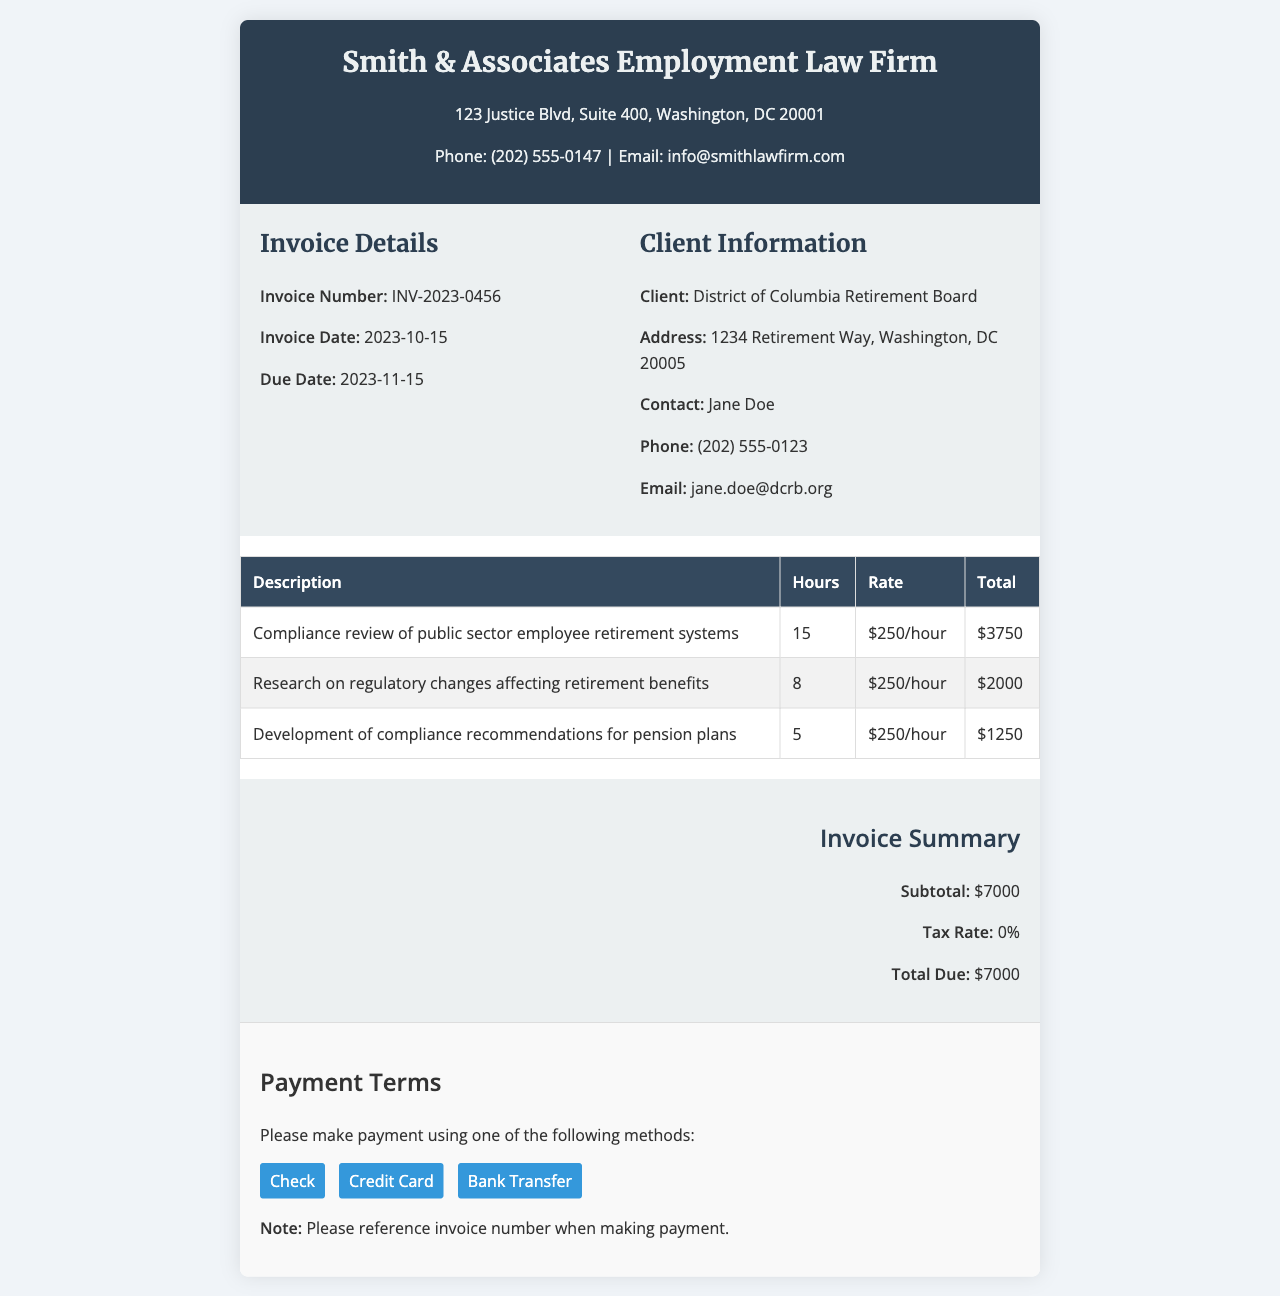what is the invoice number? The invoice number is listed under Invoice Details in the document.
Answer: INV-2023-0456 what is the total due? The total due is summarized at the end of the invoice.
Answer: $7000 who is the client? The client information is presented in the document under Client Information.
Answer: District of Columbia Retirement Board how many hours were spent on compliance review? The hours for compliance review are detailed in the services table.
Answer: 15 what is the due date of the invoice? The due date can be found in the Invoice Details section.
Answer: 2023-11-15 what is the tax rate applied to the invoice? The tax rate is part of the invoice summary section.
Answer: 0% how much time was dedicated to researching regulatory changes? This information is found in the services table.
Answer: 8 how many total services are listed in the invoice? The invoice lists services in a table, and the total count is deduced by counting the rows.
Answer: 3 what is the hourly rate charged? The hourly rate is stated in the services table for each item.
Answer: $250/hour 